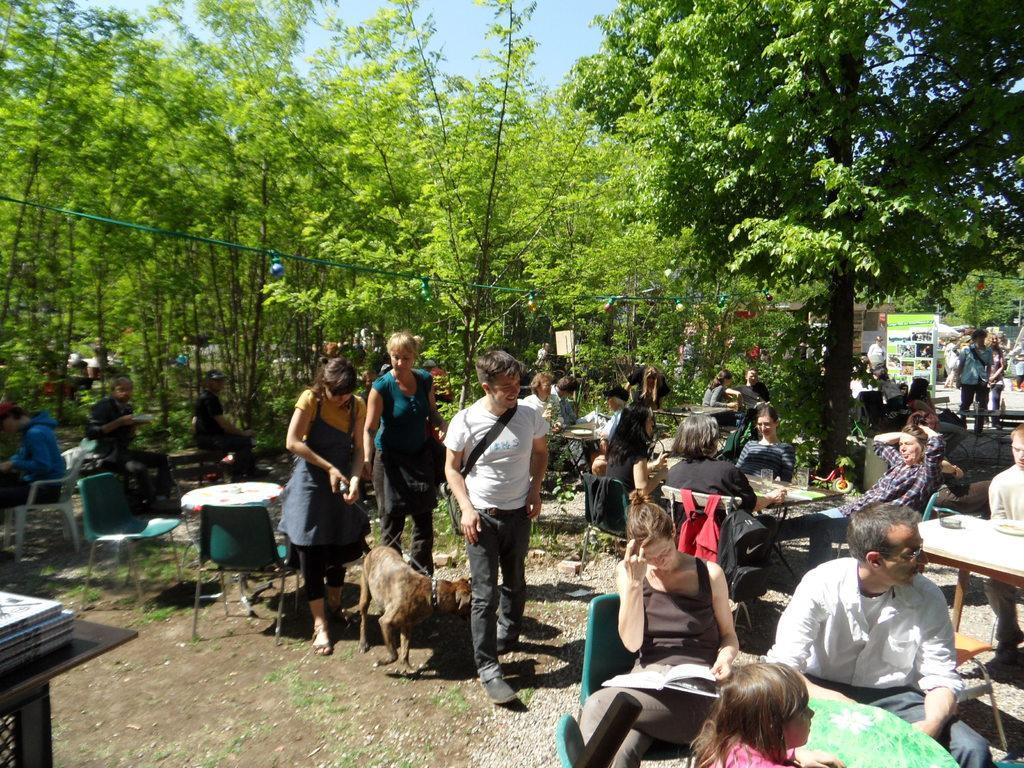Describe this image in one or two sentences. As we can see in the image there are trees and few people sitting and standing here and there and there is a dog over here. On tables there are glasses. 